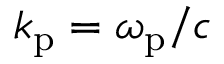Convert formula to latex. <formula><loc_0><loc_0><loc_500><loc_500>k _ { p } = \omega _ { p } / { c }</formula> 